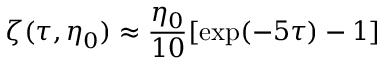Convert formula to latex. <formula><loc_0><loc_0><loc_500><loc_500>\zeta ( \tau , \eta _ { 0 } ) \approx \frac { \eta _ { 0 } } { 1 0 } [ \exp ( - 5 \tau ) - 1 ]</formula> 